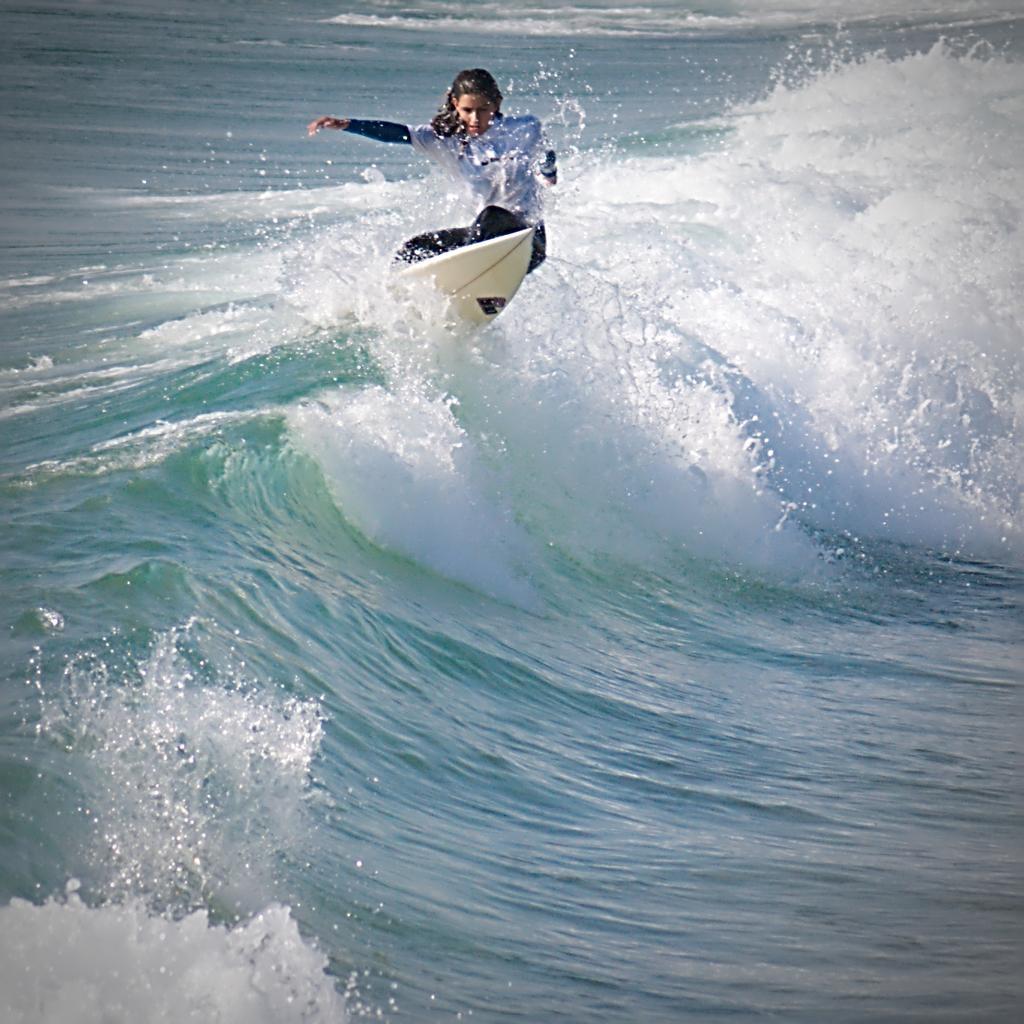How would you summarize this image in a sentence or two? In this picture there is a girl wearing white and black color costume doing the surfing board on the sea water. Behind there is a water waves. 